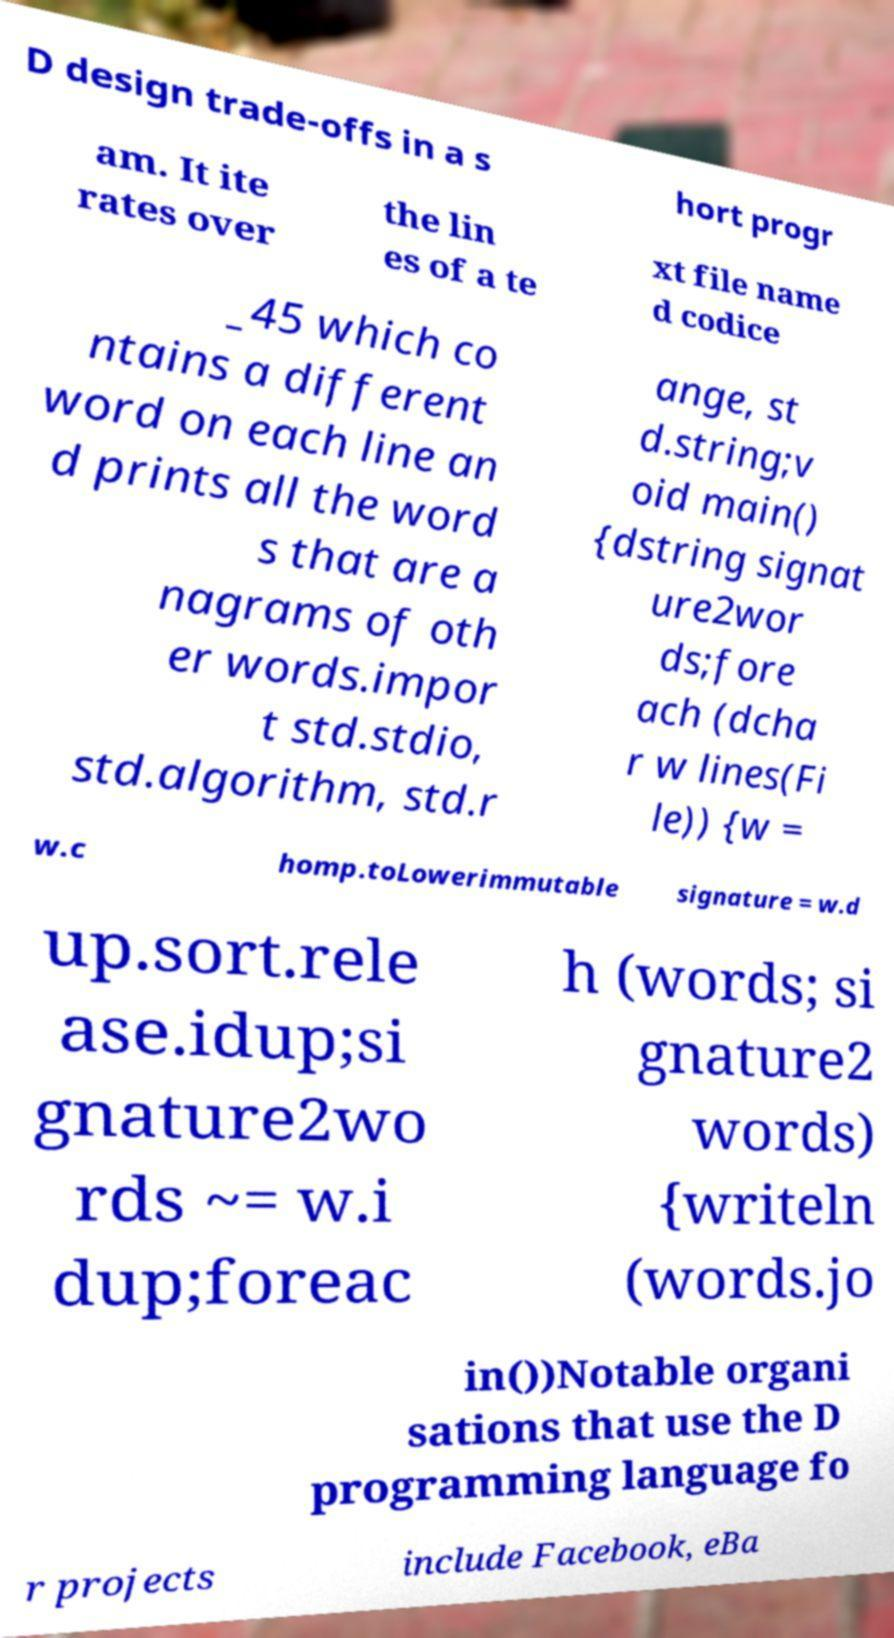What messages or text are displayed in this image? I need them in a readable, typed format. D design trade-offs in a s hort progr am. It ite rates over the lin es of a te xt file name d codice _45 which co ntains a different word on each line an d prints all the word s that are a nagrams of oth er words.impor t std.stdio, std.algorithm, std.r ange, st d.string;v oid main() {dstring signat ure2wor ds;fore ach (dcha r w lines(Fi le)) {w = w.c homp.toLowerimmutable signature = w.d up.sort.rele ase.idup;si gnature2wo rds ~= w.i dup;foreac h (words; si gnature2 words) {writeln (words.jo in())Notable organi sations that use the D programming language fo r projects include Facebook, eBa 